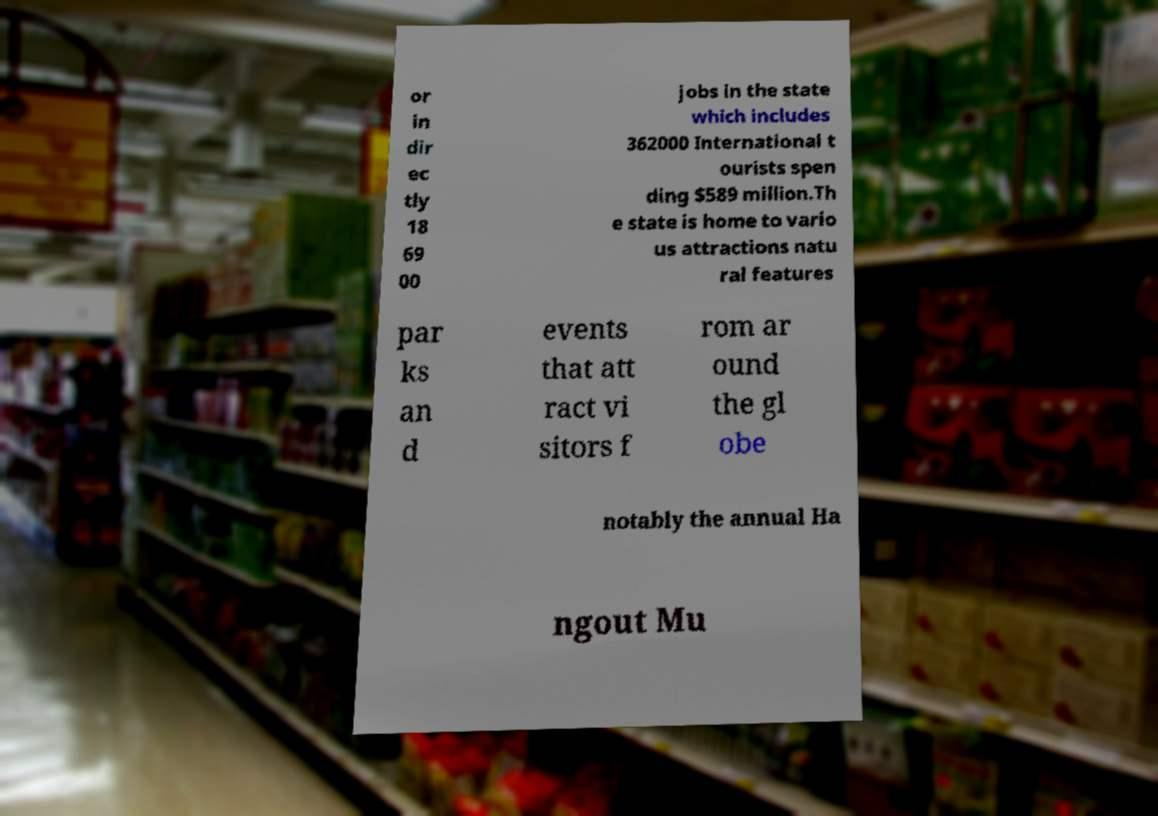Can you accurately transcribe the text from the provided image for me? or in dir ec tly 18 69 00 jobs in the state which includes 362000 International t ourists spen ding $589 million.Th e state is home to vario us attractions natu ral features par ks an d events that att ract vi sitors f rom ar ound the gl obe notably the annual Ha ngout Mu 